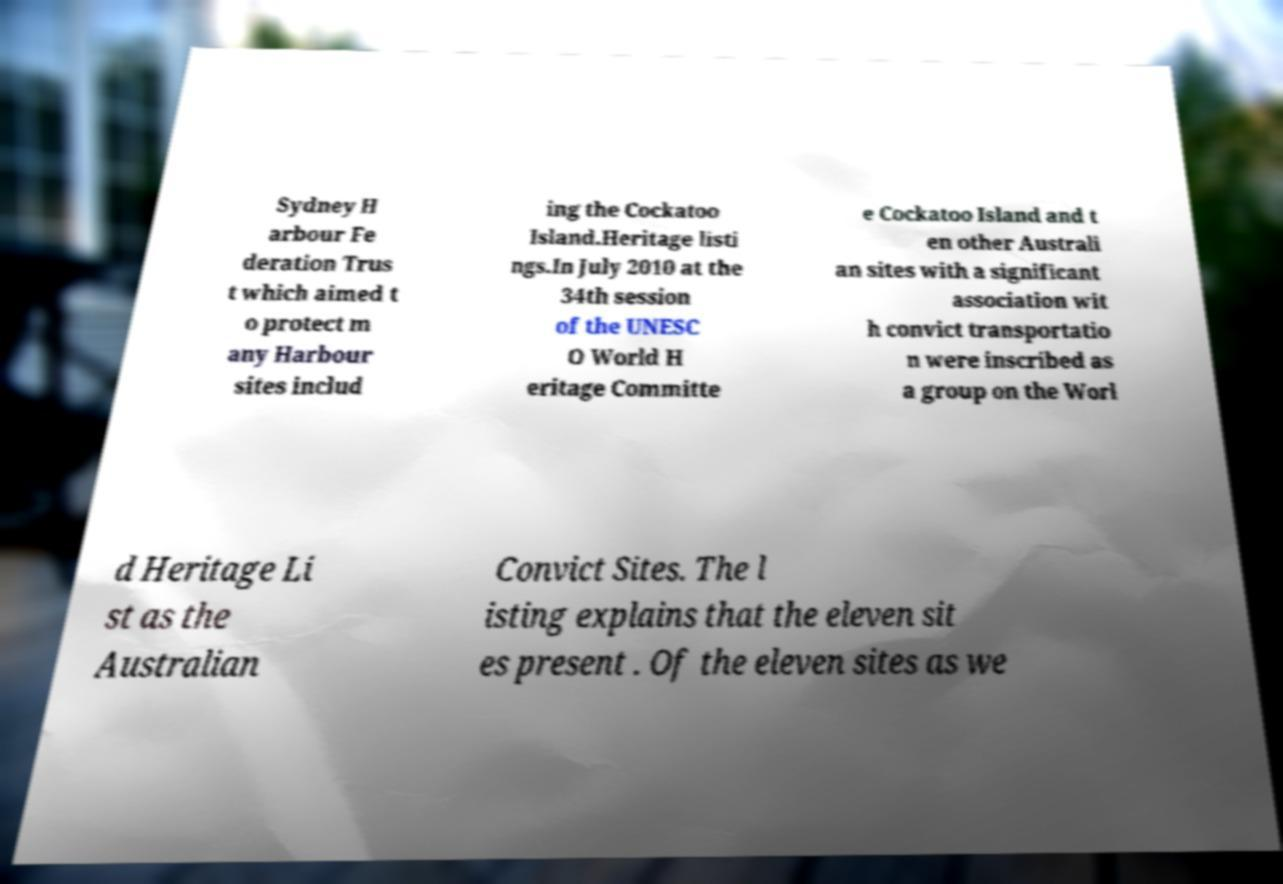Please identify and transcribe the text found in this image. Sydney H arbour Fe deration Trus t which aimed t o protect m any Harbour sites includ ing the Cockatoo Island.Heritage listi ngs.In July 2010 at the 34th session of the UNESC O World H eritage Committe e Cockatoo Island and t en other Australi an sites with a significant association wit h convict transportatio n were inscribed as a group on the Worl d Heritage Li st as the Australian Convict Sites. The l isting explains that the eleven sit es present . Of the eleven sites as we 